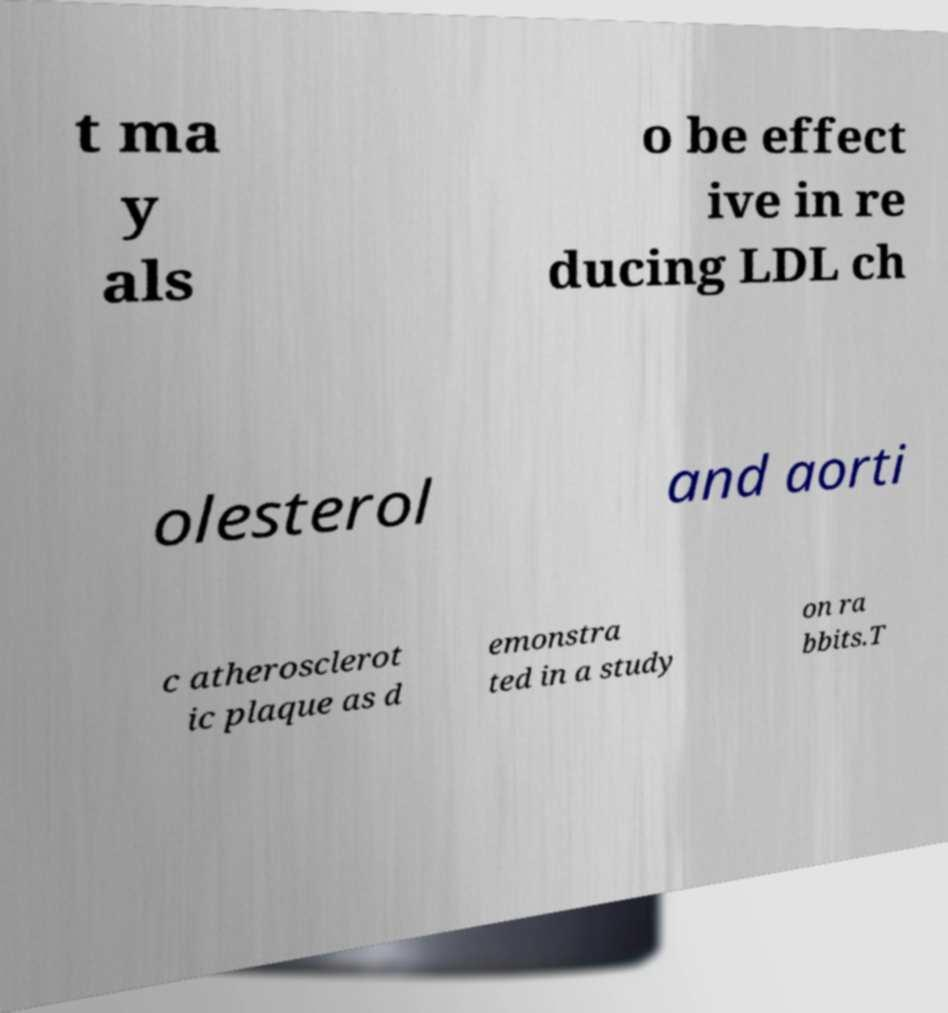Please read and relay the text visible in this image. What does it say? t ma y als o be effect ive in re ducing LDL ch olesterol and aorti c atherosclerot ic plaque as d emonstra ted in a study on ra bbits.T 